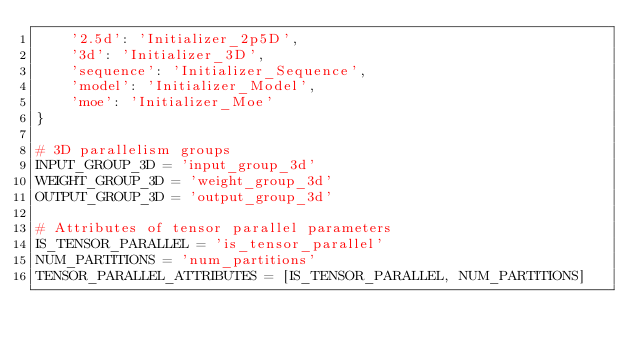Convert code to text. <code><loc_0><loc_0><loc_500><loc_500><_Python_>    '2.5d': 'Initializer_2p5D',
    '3d': 'Initializer_3D',
    'sequence': 'Initializer_Sequence',
    'model': 'Initializer_Model',
    'moe': 'Initializer_Moe'
}

# 3D parallelism groups
INPUT_GROUP_3D = 'input_group_3d'
WEIGHT_GROUP_3D = 'weight_group_3d'
OUTPUT_GROUP_3D = 'output_group_3d'

# Attributes of tensor parallel parameters 
IS_TENSOR_PARALLEL = 'is_tensor_parallel'
NUM_PARTITIONS = 'num_partitions'
TENSOR_PARALLEL_ATTRIBUTES = [IS_TENSOR_PARALLEL, NUM_PARTITIONS]
</code> 